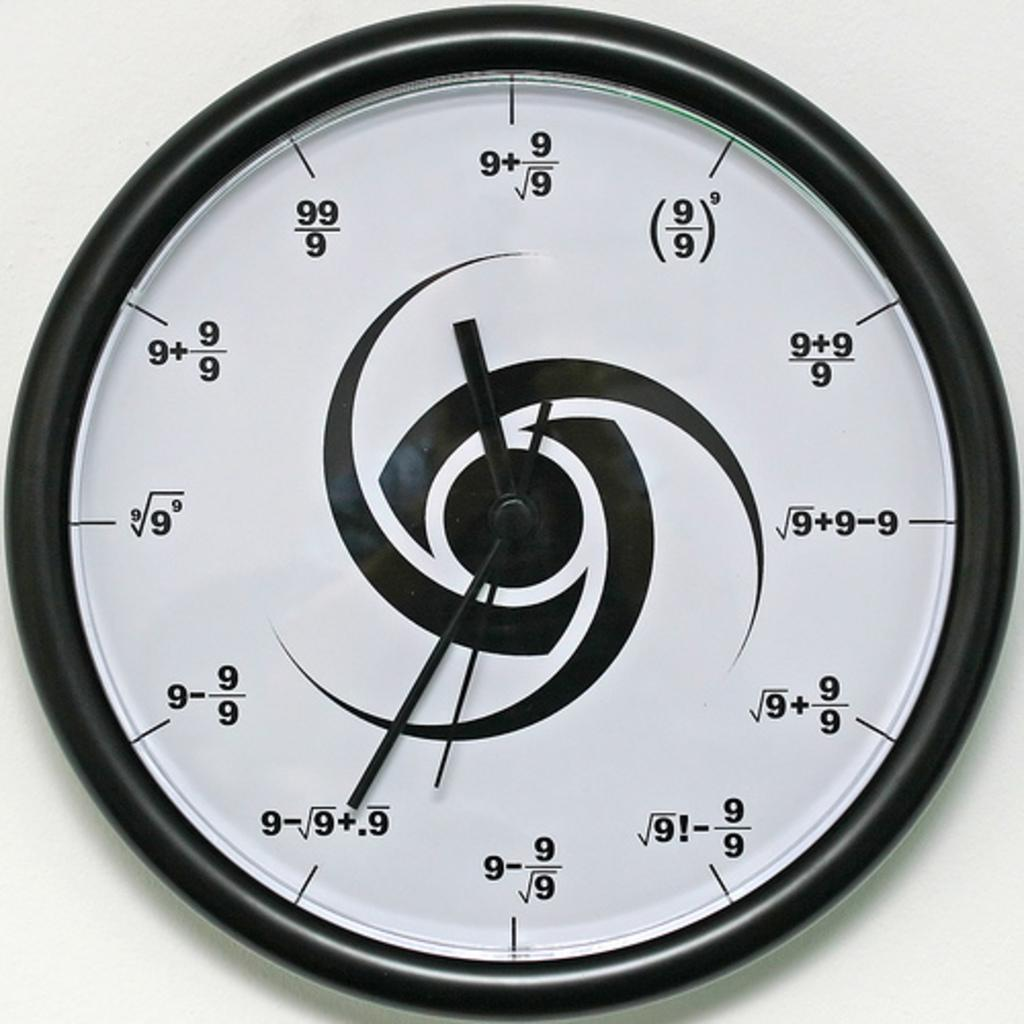<image>
Relay a brief, clear account of the picture shown. Clock that gives the time in math problems with 9's says it is 11:35 